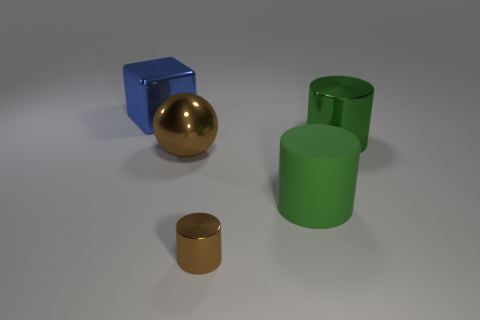Subtract all green matte cylinders. How many cylinders are left? 2 Add 1 purple blocks. How many objects exist? 6 Subtract all brown cylinders. How many cylinders are left? 2 Subtract all cubes. How many objects are left? 4 Subtract 0 purple cubes. How many objects are left? 5 Subtract 1 blocks. How many blocks are left? 0 Subtract all green spheres. Subtract all yellow cylinders. How many spheres are left? 1 Subtract all blue blocks. How many red cylinders are left? 0 Subtract all red blocks. Subtract all big blue cubes. How many objects are left? 4 Add 5 large brown spheres. How many large brown spheres are left? 6 